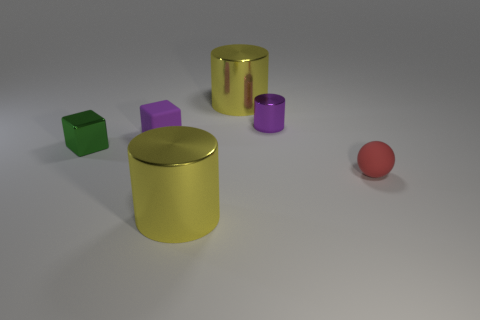Subtract all large cylinders. How many cylinders are left? 1 Add 1 small red rubber spheres. How many objects exist? 7 Subtract all cyan spheres. How many yellow cylinders are left? 2 Subtract all blocks. How many objects are left? 4 Subtract all purple cubes. How many cubes are left? 1 Subtract all large cyan shiny spheres. Subtract all green shiny things. How many objects are left? 5 Add 5 large objects. How many large objects are left? 7 Add 4 shiny cylinders. How many shiny cylinders exist? 7 Subtract 1 purple blocks. How many objects are left? 5 Subtract 2 blocks. How many blocks are left? 0 